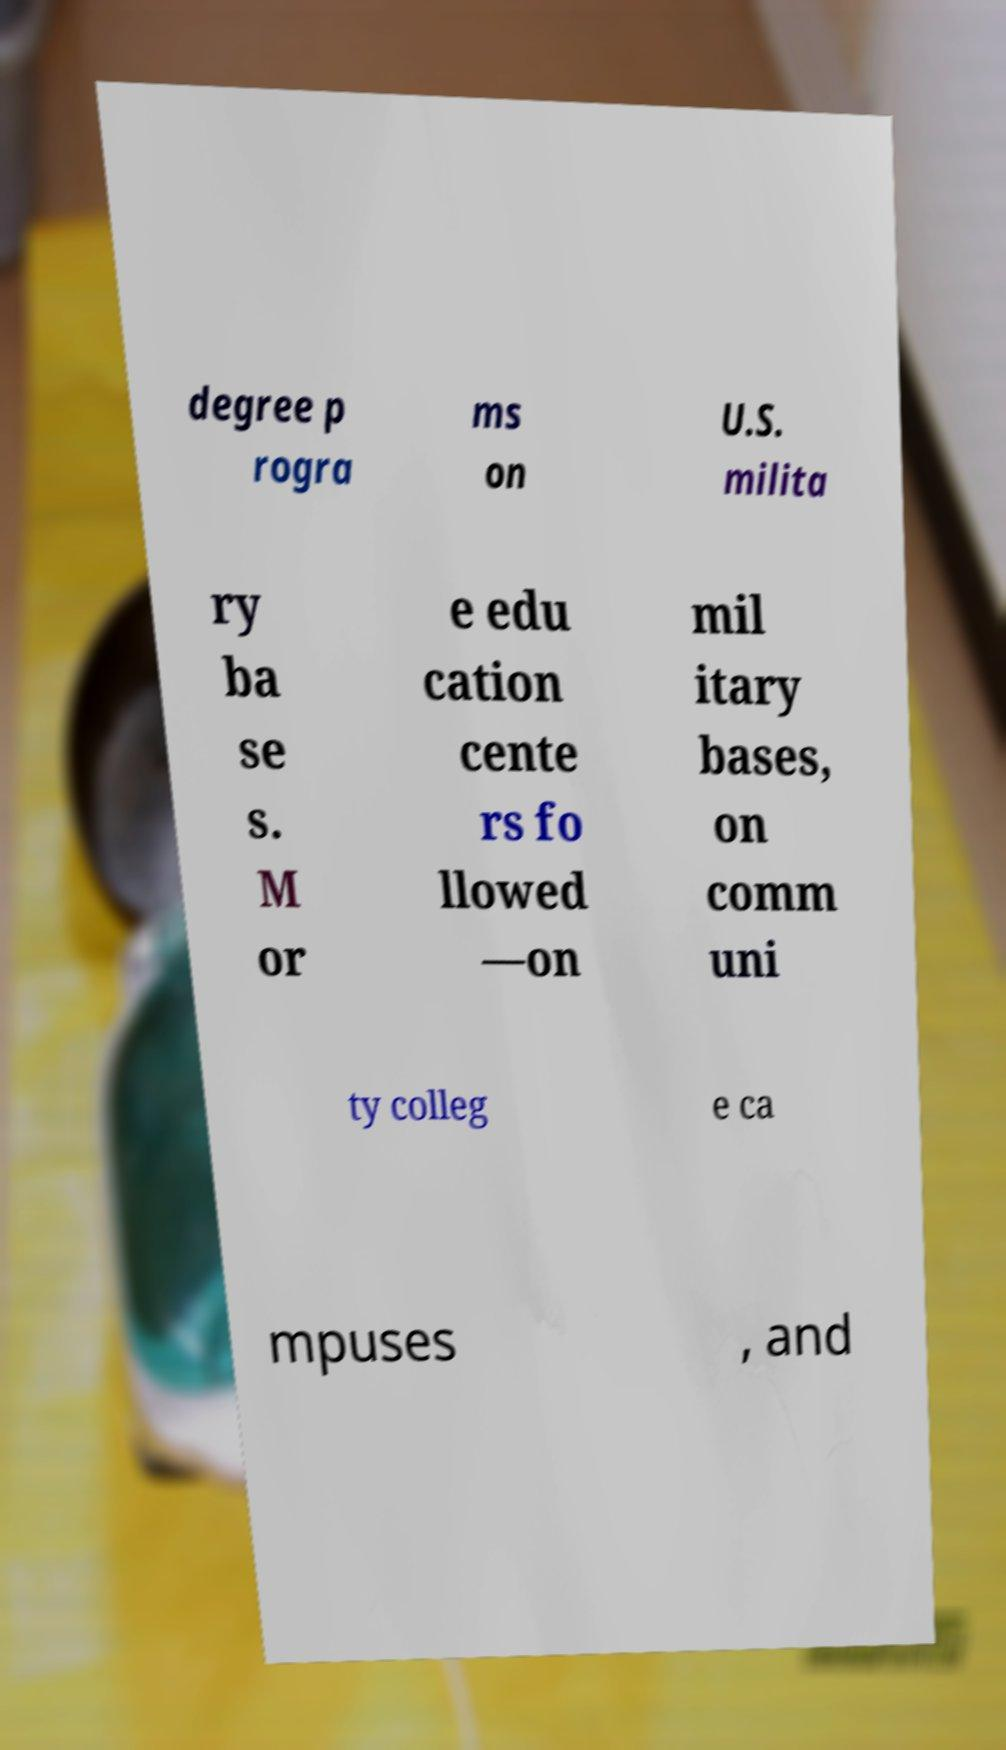There's text embedded in this image that I need extracted. Can you transcribe it verbatim? degree p rogra ms on U.S. milita ry ba se s. M or e edu cation cente rs fo llowed —on mil itary bases, on comm uni ty colleg e ca mpuses , and 